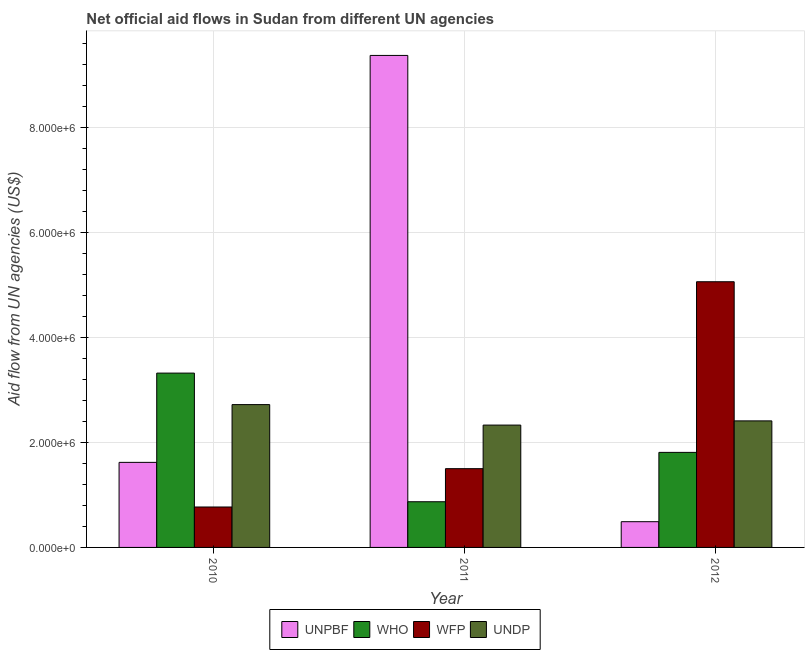How many different coloured bars are there?
Ensure brevity in your answer.  4. How many groups of bars are there?
Your answer should be very brief. 3. How many bars are there on the 2nd tick from the right?
Provide a short and direct response. 4. What is the label of the 2nd group of bars from the left?
Offer a terse response. 2011. What is the amount of aid given by who in 2012?
Your answer should be very brief. 1.81e+06. Across all years, what is the maximum amount of aid given by undp?
Your answer should be compact. 2.72e+06. Across all years, what is the minimum amount of aid given by wfp?
Your response must be concise. 7.70e+05. In which year was the amount of aid given by wfp minimum?
Offer a very short reply. 2010. What is the total amount of aid given by wfp in the graph?
Ensure brevity in your answer.  7.33e+06. What is the difference between the amount of aid given by unpbf in 2010 and that in 2011?
Your answer should be very brief. -7.75e+06. What is the difference between the amount of aid given by unpbf in 2012 and the amount of aid given by undp in 2011?
Provide a short and direct response. -8.88e+06. What is the average amount of aid given by undp per year?
Make the answer very short. 2.49e+06. In the year 2012, what is the difference between the amount of aid given by wfp and amount of aid given by who?
Ensure brevity in your answer.  0. What is the ratio of the amount of aid given by wfp in 2011 to that in 2012?
Keep it short and to the point. 0.3. What is the difference between the highest and the second highest amount of aid given by wfp?
Your response must be concise. 3.56e+06. What is the difference between the highest and the lowest amount of aid given by who?
Make the answer very short. 2.45e+06. Is it the case that in every year, the sum of the amount of aid given by wfp and amount of aid given by who is greater than the sum of amount of aid given by undp and amount of aid given by unpbf?
Give a very brief answer. No. What does the 4th bar from the left in 2011 represents?
Provide a succinct answer. UNDP. What does the 3rd bar from the right in 2011 represents?
Make the answer very short. WHO. Is it the case that in every year, the sum of the amount of aid given by unpbf and amount of aid given by who is greater than the amount of aid given by wfp?
Give a very brief answer. No. How many years are there in the graph?
Provide a succinct answer. 3. What is the difference between two consecutive major ticks on the Y-axis?
Your answer should be compact. 2.00e+06. Does the graph contain grids?
Provide a succinct answer. Yes. Where does the legend appear in the graph?
Offer a terse response. Bottom center. How are the legend labels stacked?
Give a very brief answer. Horizontal. What is the title of the graph?
Your answer should be very brief. Net official aid flows in Sudan from different UN agencies. Does "Budget management" appear as one of the legend labels in the graph?
Make the answer very short. No. What is the label or title of the X-axis?
Your answer should be very brief. Year. What is the label or title of the Y-axis?
Make the answer very short. Aid flow from UN agencies (US$). What is the Aid flow from UN agencies (US$) in UNPBF in 2010?
Your answer should be compact. 1.62e+06. What is the Aid flow from UN agencies (US$) in WHO in 2010?
Your response must be concise. 3.32e+06. What is the Aid flow from UN agencies (US$) of WFP in 2010?
Make the answer very short. 7.70e+05. What is the Aid flow from UN agencies (US$) of UNDP in 2010?
Make the answer very short. 2.72e+06. What is the Aid flow from UN agencies (US$) of UNPBF in 2011?
Your answer should be very brief. 9.37e+06. What is the Aid flow from UN agencies (US$) of WHO in 2011?
Your answer should be compact. 8.70e+05. What is the Aid flow from UN agencies (US$) in WFP in 2011?
Your answer should be very brief. 1.50e+06. What is the Aid flow from UN agencies (US$) in UNDP in 2011?
Give a very brief answer. 2.33e+06. What is the Aid flow from UN agencies (US$) in UNPBF in 2012?
Provide a succinct answer. 4.90e+05. What is the Aid flow from UN agencies (US$) in WHO in 2012?
Your answer should be very brief. 1.81e+06. What is the Aid flow from UN agencies (US$) in WFP in 2012?
Make the answer very short. 5.06e+06. What is the Aid flow from UN agencies (US$) in UNDP in 2012?
Offer a very short reply. 2.41e+06. Across all years, what is the maximum Aid flow from UN agencies (US$) of UNPBF?
Give a very brief answer. 9.37e+06. Across all years, what is the maximum Aid flow from UN agencies (US$) of WHO?
Provide a short and direct response. 3.32e+06. Across all years, what is the maximum Aid flow from UN agencies (US$) in WFP?
Provide a succinct answer. 5.06e+06. Across all years, what is the maximum Aid flow from UN agencies (US$) in UNDP?
Your answer should be compact. 2.72e+06. Across all years, what is the minimum Aid flow from UN agencies (US$) of WHO?
Give a very brief answer. 8.70e+05. Across all years, what is the minimum Aid flow from UN agencies (US$) in WFP?
Keep it short and to the point. 7.70e+05. Across all years, what is the minimum Aid flow from UN agencies (US$) of UNDP?
Offer a very short reply. 2.33e+06. What is the total Aid flow from UN agencies (US$) in UNPBF in the graph?
Your answer should be compact. 1.15e+07. What is the total Aid flow from UN agencies (US$) of WFP in the graph?
Keep it short and to the point. 7.33e+06. What is the total Aid flow from UN agencies (US$) in UNDP in the graph?
Your response must be concise. 7.46e+06. What is the difference between the Aid flow from UN agencies (US$) of UNPBF in 2010 and that in 2011?
Give a very brief answer. -7.75e+06. What is the difference between the Aid flow from UN agencies (US$) of WHO in 2010 and that in 2011?
Make the answer very short. 2.45e+06. What is the difference between the Aid flow from UN agencies (US$) in WFP in 2010 and that in 2011?
Provide a succinct answer. -7.30e+05. What is the difference between the Aid flow from UN agencies (US$) in UNPBF in 2010 and that in 2012?
Provide a short and direct response. 1.13e+06. What is the difference between the Aid flow from UN agencies (US$) in WHO in 2010 and that in 2012?
Your answer should be compact. 1.51e+06. What is the difference between the Aid flow from UN agencies (US$) of WFP in 2010 and that in 2012?
Your answer should be compact. -4.29e+06. What is the difference between the Aid flow from UN agencies (US$) of UNDP in 2010 and that in 2012?
Offer a terse response. 3.10e+05. What is the difference between the Aid flow from UN agencies (US$) in UNPBF in 2011 and that in 2012?
Give a very brief answer. 8.88e+06. What is the difference between the Aid flow from UN agencies (US$) in WHO in 2011 and that in 2012?
Keep it short and to the point. -9.40e+05. What is the difference between the Aid flow from UN agencies (US$) of WFP in 2011 and that in 2012?
Provide a succinct answer. -3.56e+06. What is the difference between the Aid flow from UN agencies (US$) in UNPBF in 2010 and the Aid flow from UN agencies (US$) in WHO in 2011?
Provide a short and direct response. 7.50e+05. What is the difference between the Aid flow from UN agencies (US$) in UNPBF in 2010 and the Aid flow from UN agencies (US$) in WFP in 2011?
Your answer should be compact. 1.20e+05. What is the difference between the Aid flow from UN agencies (US$) of UNPBF in 2010 and the Aid flow from UN agencies (US$) of UNDP in 2011?
Make the answer very short. -7.10e+05. What is the difference between the Aid flow from UN agencies (US$) of WHO in 2010 and the Aid flow from UN agencies (US$) of WFP in 2011?
Your response must be concise. 1.82e+06. What is the difference between the Aid flow from UN agencies (US$) in WHO in 2010 and the Aid flow from UN agencies (US$) in UNDP in 2011?
Give a very brief answer. 9.90e+05. What is the difference between the Aid flow from UN agencies (US$) in WFP in 2010 and the Aid flow from UN agencies (US$) in UNDP in 2011?
Your answer should be very brief. -1.56e+06. What is the difference between the Aid flow from UN agencies (US$) in UNPBF in 2010 and the Aid flow from UN agencies (US$) in WHO in 2012?
Give a very brief answer. -1.90e+05. What is the difference between the Aid flow from UN agencies (US$) in UNPBF in 2010 and the Aid flow from UN agencies (US$) in WFP in 2012?
Provide a succinct answer. -3.44e+06. What is the difference between the Aid flow from UN agencies (US$) of UNPBF in 2010 and the Aid flow from UN agencies (US$) of UNDP in 2012?
Your answer should be very brief. -7.90e+05. What is the difference between the Aid flow from UN agencies (US$) of WHO in 2010 and the Aid flow from UN agencies (US$) of WFP in 2012?
Your answer should be very brief. -1.74e+06. What is the difference between the Aid flow from UN agencies (US$) in WHO in 2010 and the Aid flow from UN agencies (US$) in UNDP in 2012?
Ensure brevity in your answer.  9.10e+05. What is the difference between the Aid flow from UN agencies (US$) of WFP in 2010 and the Aid flow from UN agencies (US$) of UNDP in 2012?
Your answer should be very brief. -1.64e+06. What is the difference between the Aid flow from UN agencies (US$) of UNPBF in 2011 and the Aid flow from UN agencies (US$) of WHO in 2012?
Provide a succinct answer. 7.56e+06. What is the difference between the Aid flow from UN agencies (US$) in UNPBF in 2011 and the Aid flow from UN agencies (US$) in WFP in 2012?
Provide a succinct answer. 4.31e+06. What is the difference between the Aid flow from UN agencies (US$) of UNPBF in 2011 and the Aid flow from UN agencies (US$) of UNDP in 2012?
Keep it short and to the point. 6.96e+06. What is the difference between the Aid flow from UN agencies (US$) in WHO in 2011 and the Aid flow from UN agencies (US$) in WFP in 2012?
Make the answer very short. -4.19e+06. What is the difference between the Aid flow from UN agencies (US$) in WHO in 2011 and the Aid flow from UN agencies (US$) in UNDP in 2012?
Offer a very short reply. -1.54e+06. What is the difference between the Aid flow from UN agencies (US$) of WFP in 2011 and the Aid flow from UN agencies (US$) of UNDP in 2012?
Your response must be concise. -9.10e+05. What is the average Aid flow from UN agencies (US$) of UNPBF per year?
Offer a very short reply. 3.83e+06. What is the average Aid flow from UN agencies (US$) in WFP per year?
Offer a very short reply. 2.44e+06. What is the average Aid flow from UN agencies (US$) of UNDP per year?
Provide a short and direct response. 2.49e+06. In the year 2010, what is the difference between the Aid flow from UN agencies (US$) of UNPBF and Aid flow from UN agencies (US$) of WHO?
Your response must be concise. -1.70e+06. In the year 2010, what is the difference between the Aid flow from UN agencies (US$) in UNPBF and Aid flow from UN agencies (US$) in WFP?
Your response must be concise. 8.50e+05. In the year 2010, what is the difference between the Aid flow from UN agencies (US$) of UNPBF and Aid flow from UN agencies (US$) of UNDP?
Ensure brevity in your answer.  -1.10e+06. In the year 2010, what is the difference between the Aid flow from UN agencies (US$) of WHO and Aid flow from UN agencies (US$) of WFP?
Your answer should be very brief. 2.55e+06. In the year 2010, what is the difference between the Aid flow from UN agencies (US$) in WFP and Aid flow from UN agencies (US$) in UNDP?
Give a very brief answer. -1.95e+06. In the year 2011, what is the difference between the Aid flow from UN agencies (US$) of UNPBF and Aid flow from UN agencies (US$) of WHO?
Offer a terse response. 8.50e+06. In the year 2011, what is the difference between the Aid flow from UN agencies (US$) of UNPBF and Aid flow from UN agencies (US$) of WFP?
Provide a short and direct response. 7.87e+06. In the year 2011, what is the difference between the Aid flow from UN agencies (US$) of UNPBF and Aid flow from UN agencies (US$) of UNDP?
Make the answer very short. 7.04e+06. In the year 2011, what is the difference between the Aid flow from UN agencies (US$) in WHO and Aid flow from UN agencies (US$) in WFP?
Provide a succinct answer. -6.30e+05. In the year 2011, what is the difference between the Aid flow from UN agencies (US$) in WHO and Aid flow from UN agencies (US$) in UNDP?
Make the answer very short. -1.46e+06. In the year 2011, what is the difference between the Aid flow from UN agencies (US$) of WFP and Aid flow from UN agencies (US$) of UNDP?
Your response must be concise. -8.30e+05. In the year 2012, what is the difference between the Aid flow from UN agencies (US$) of UNPBF and Aid flow from UN agencies (US$) of WHO?
Offer a terse response. -1.32e+06. In the year 2012, what is the difference between the Aid flow from UN agencies (US$) in UNPBF and Aid flow from UN agencies (US$) in WFP?
Offer a very short reply. -4.57e+06. In the year 2012, what is the difference between the Aid flow from UN agencies (US$) of UNPBF and Aid flow from UN agencies (US$) of UNDP?
Make the answer very short. -1.92e+06. In the year 2012, what is the difference between the Aid flow from UN agencies (US$) of WHO and Aid flow from UN agencies (US$) of WFP?
Your answer should be compact. -3.25e+06. In the year 2012, what is the difference between the Aid flow from UN agencies (US$) of WHO and Aid flow from UN agencies (US$) of UNDP?
Offer a terse response. -6.00e+05. In the year 2012, what is the difference between the Aid flow from UN agencies (US$) of WFP and Aid flow from UN agencies (US$) of UNDP?
Make the answer very short. 2.65e+06. What is the ratio of the Aid flow from UN agencies (US$) of UNPBF in 2010 to that in 2011?
Your response must be concise. 0.17. What is the ratio of the Aid flow from UN agencies (US$) in WHO in 2010 to that in 2011?
Offer a very short reply. 3.82. What is the ratio of the Aid flow from UN agencies (US$) in WFP in 2010 to that in 2011?
Keep it short and to the point. 0.51. What is the ratio of the Aid flow from UN agencies (US$) in UNDP in 2010 to that in 2011?
Provide a short and direct response. 1.17. What is the ratio of the Aid flow from UN agencies (US$) of UNPBF in 2010 to that in 2012?
Provide a short and direct response. 3.31. What is the ratio of the Aid flow from UN agencies (US$) in WHO in 2010 to that in 2012?
Keep it short and to the point. 1.83. What is the ratio of the Aid flow from UN agencies (US$) of WFP in 2010 to that in 2012?
Provide a succinct answer. 0.15. What is the ratio of the Aid flow from UN agencies (US$) in UNDP in 2010 to that in 2012?
Provide a short and direct response. 1.13. What is the ratio of the Aid flow from UN agencies (US$) in UNPBF in 2011 to that in 2012?
Your answer should be compact. 19.12. What is the ratio of the Aid flow from UN agencies (US$) in WHO in 2011 to that in 2012?
Make the answer very short. 0.48. What is the ratio of the Aid flow from UN agencies (US$) in WFP in 2011 to that in 2012?
Offer a terse response. 0.3. What is the ratio of the Aid flow from UN agencies (US$) in UNDP in 2011 to that in 2012?
Provide a succinct answer. 0.97. What is the difference between the highest and the second highest Aid flow from UN agencies (US$) in UNPBF?
Offer a terse response. 7.75e+06. What is the difference between the highest and the second highest Aid flow from UN agencies (US$) in WHO?
Provide a short and direct response. 1.51e+06. What is the difference between the highest and the second highest Aid flow from UN agencies (US$) of WFP?
Your response must be concise. 3.56e+06. What is the difference between the highest and the second highest Aid flow from UN agencies (US$) in UNDP?
Your answer should be very brief. 3.10e+05. What is the difference between the highest and the lowest Aid flow from UN agencies (US$) of UNPBF?
Make the answer very short. 8.88e+06. What is the difference between the highest and the lowest Aid flow from UN agencies (US$) of WHO?
Ensure brevity in your answer.  2.45e+06. What is the difference between the highest and the lowest Aid flow from UN agencies (US$) of WFP?
Your answer should be very brief. 4.29e+06. 